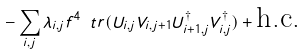Convert formula to latex. <formula><loc_0><loc_0><loc_500><loc_500>- \sum _ { i , j } \lambda _ { i , j } f ^ { 4 } \ t r ( U _ { i , j } V _ { i , j + 1 } U ^ { \dagger } _ { i + 1 , j } V ^ { \dagger } _ { i , j } ) + \text {h.c.}</formula> 